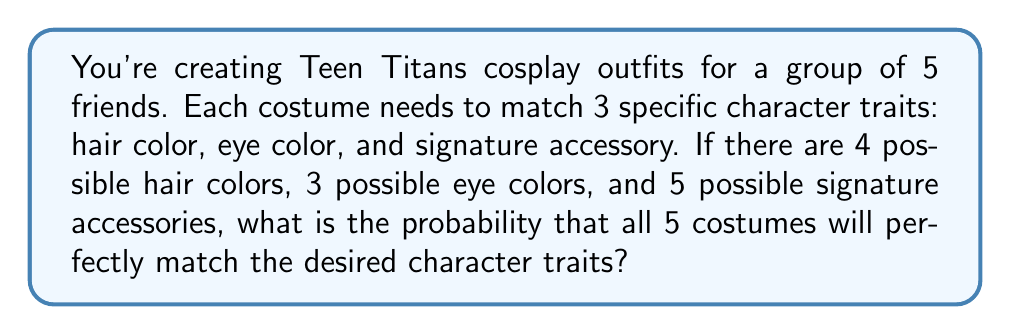Give your solution to this math problem. Let's approach this step-by-step using combinatorics:

1) For each costume, we need to match 3 traits:
   - Hair color: 4 options
   - Eye color: 3 options
   - Signature accessory: 5 options

2) The total number of possible combinations for one costume is:
   $$ 4 \times 3 \times 5 = 60 $$

3) The probability of getting one costume exactly right is:
   $$ \frac{1}{60} $$

4) We need all 5 costumes to be correct. This is an independent event for each costume, so we multiply the probabilities:
   $$ P(\text{all correct}) = \left(\frac{1}{60}\right)^5 $$

5) Let's calculate this:
   $$ \left(\frac{1}{60}\right)^5 = \frac{1}{60^5} = \frac{1}{777,600,000} $$

6) To express this as a decimal:
   $$ \frac{1}{777,600,000} \approx 1.2860082304526748 \times 10^{-9} $$

Thus, the probability of all 5 costumes perfectly matching the desired character traits is approximately $1.29 \times 10^{-9}$ or about 1 in 777.6 million.
Answer: $1.29 \times 10^{-9}$ 